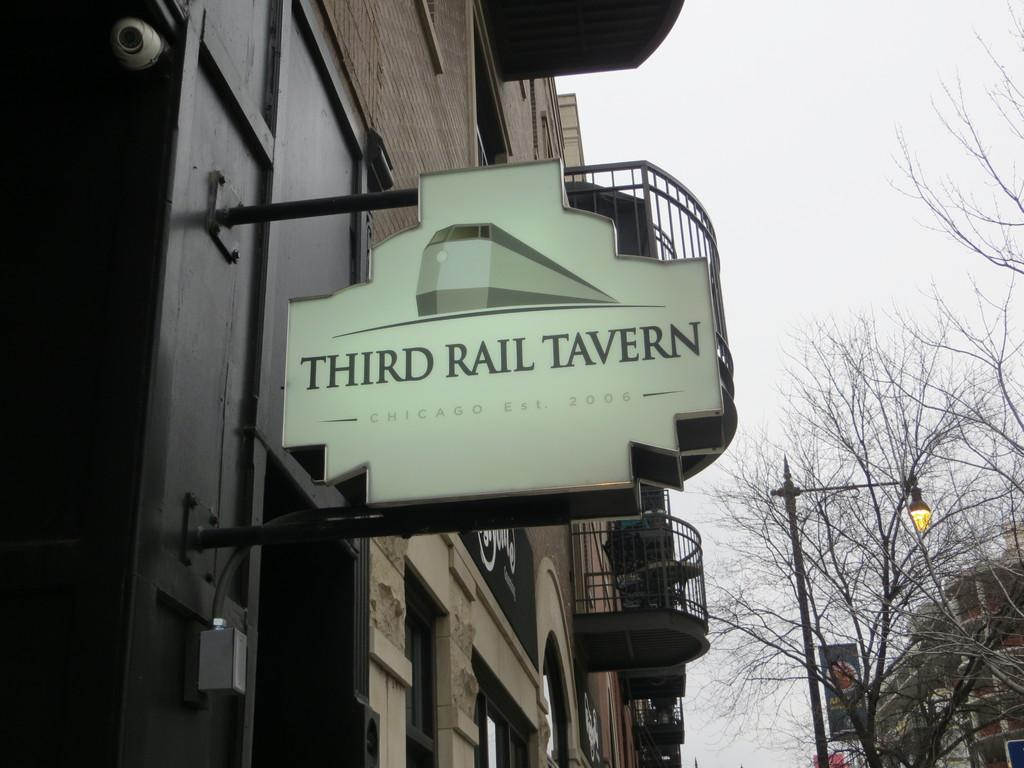What type of structures are visible in the image? There are buildings with windows in the image. What can be found near the buildings? There is a name board and a banner in the image. What type of vegetation is present in the image? There are trees in the image. What other objects can be seen in the image? There is a pole and a lamp in the image. What is visible in the background of the image? The sky is visible in the background of the image. What type of gun is being fired in the image? There is no gun or any indication of firing in the image. What kind of cannon is present in the image? There is no cannon present in the image. 